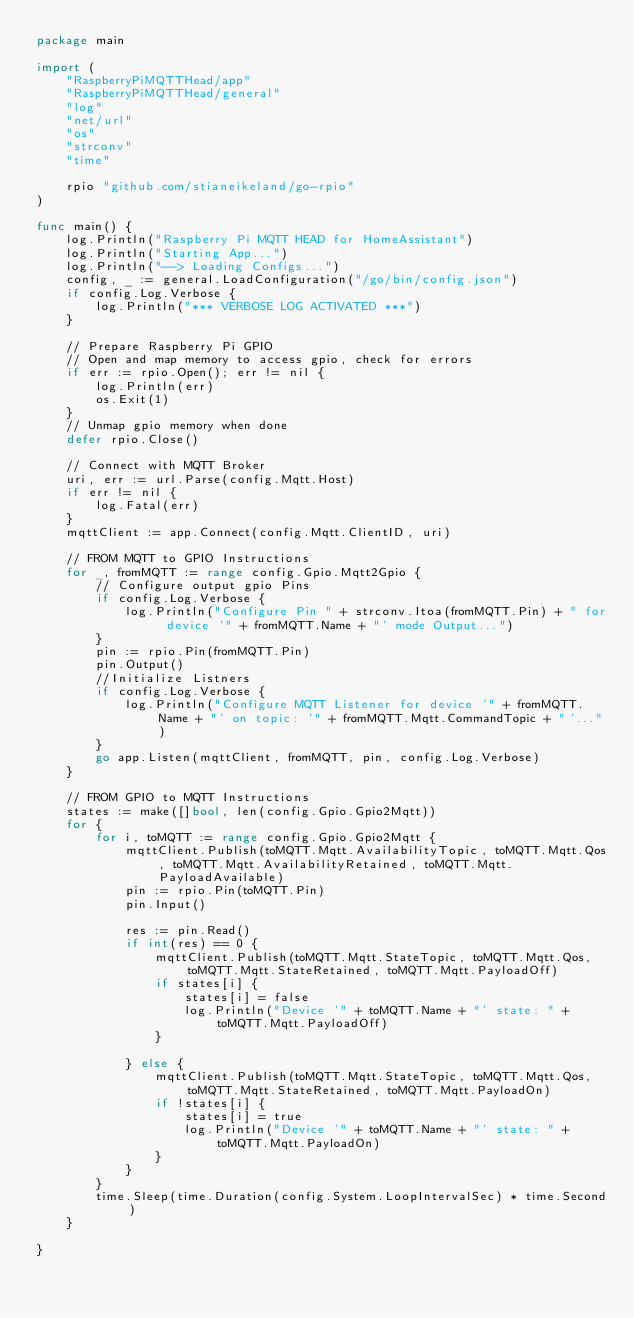Convert code to text. <code><loc_0><loc_0><loc_500><loc_500><_Go_>package main

import (
	"RaspberryPiMQTTHead/app"
	"RaspberryPiMQTTHead/general"
	"log"
	"net/url"
	"os"
	"strconv"
	"time"

	rpio "github.com/stianeikeland/go-rpio"
)

func main() {
	log.Println("Raspberry Pi MQTT HEAD for HomeAssistant")
	log.Println("Starting App...")
	log.Println("--> Loading Configs...")
	config, _ := general.LoadConfiguration("/go/bin/config.json")
	if config.Log.Verbose {
		log.Println("*** VERBOSE LOG ACTIVATED ***")
	}

	// Prepare Raspberry Pi GPIO
	// Open and map memory to access gpio, check for errors
	if err := rpio.Open(); err != nil {
		log.Println(err)
		os.Exit(1)
	}
	// Unmap gpio memory when done
	defer rpio.Close()

	// Connect with MQTT Broker
	uri, err := url.Parse(config.Mqtt.Host)
	if err != nil {
		log.Fatal(err)
	}
	mqttClient := app.Connect(config.Mqtt.ClientID, uri)

	// FROM MQTT to GPIO Instructions
	for _, fromMQTT := range config.Gpio.Mqtt2Gpio {
		// Configure output gpio Pins
		if config.Log.Verbose {
			log.Println("Configure Pin " + strconv.Itoa(fromMQTT.Pin) + " for device '" + fromMQTT.Name + "' mode Output...")
		}
		pin := rpio.Pin(fromMQTT.Pin)
		pin.Output()
		//Initialize Listners
		if config.Log.Verbose {
			log.Println("Configure MQTT Listener for device '" + fromMQTT.Name + "' on topic: '" + fromMQTT.Mqtt.CommandTopic + "'...")
		}
		go app.Listen(mqttClient, fromMQTT, pin, config.Log.Verbose)
	}

	// FROM GPIO to MQTT Instructions
	states := make([]bool, len(config.Gpio.Gpio2Mqtt))
	for {
		for i, toMQTT := range config.Gpio.Gpio2Mqtt {
			mqttClient.Publish(toMQTT.Mqtt.AvailabilityTopic, toMQTT.Mqtt.Qos, toMQTT.Mqtt.AvailabilityRetained, toMQTT.Mqtt.PayloadAvailable)
			pin := rpio.Pin(toMQTT.Pin)
			pin.Input()

			res := pin.Read()
			if int(res) == 0 {
				mqttClient.Publish(toMQTT.Mqtt.StateTopic, toMQTT.Mqtt.Qos, toMQTT.Mqtt.StateRetained, toMQTT.Mqtt.PayloadOff)
				if states[i] {
					states[i] = false
					log.Println("Device '" + toMQTT.Name + "' state: " + toMQTT.Mqtt.PayloadOff)
				}

			} else {
				mqttClient.Publish(toMQTT.Mqtt.StateTopic, toMQTT.Mqtt.Qos, toMQTT.Mqtt.StateRetained, toMQTT.Mqtt.PayloadOn)
				if !states[i] {
					states[i] = true
					log.Println("Device '" + toMQTT.Name + "' state: " + toMQTT.Mqtt.PayloadOn)
				}
			}
		}
		time.Sleep(time.Duration(config.System.LoopIntervalSec) * time.Second)
	}

}
</code> 